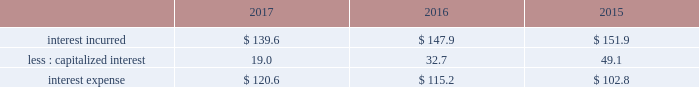Gain on previously held equity interest on 30 december 2014 , we acquired our partner 2019s equity ownership interest in a liquefied atmospheric industrial gases production joint venture in north america for $ 22.6 , which increased our ownership from 50% ( 50 % ) to 100% ( 100 % ) .
The transaction was accounted for as a business combination , and subsequent to the acquisition , the results were consolidated within our industrial gases 2013 americas segment .
We recorded a gain of $ 17.9 ( $ 11.2 after-tax , or $ .05 per share ) as a result of revaluing our previously held equity interest to fair value as of the acquisition date .
Refer to note 6 , business combination , to the consolidated financial statements for additional details .
Other income ( expense ) , net items recorded to other income ( expense ) , net arise from transactions and events not directly related to our principal income earning activities .
The detail of other income ( expense ) , net is presented in note 23 , supplemental information , to the consolidated financial statements .
2017 vs .
2016 other income ( expense ) , net of $ 121.0 increased $ 71.6 , primarily due to income from transition services agreements with versum and evonik , income from the sale of assets and investments , including a gain of $ 12.2 ( $ 7.6 after-tax , or $ .03 per share ) resulting from the sale of a parcel of land , and a favorable foreign exchange impact .
2016 vs .
2015 other income ( expense ) , net of $ 49.4 increased $ 3.9 , primarily due to lower foreign exchange losses , favorable contract settlements , and receipt of a government subsidy .
Fiscal year 2015 included a gain of $ 33.6 ( $ 28.3 after tax , or $ .13 per share ) resulting from the sale of two parcels of land .
No other individual items were significant in comparison to fiscal year 2015 .
Interest expense .
2017 vs .
2016 interest incurred decreased $ 8.3 as the impact from a lower average debt balance of $ 26 was partially offset by the impact from a higher average interest rate on the debt portfolio of $ 19 .
The change in capitalized interest was driven by a decrease in the carrying value of projects under construction , primarily as a result of our decision to exit from the energy-from-waste business .
2016 vs .
2015 interest incurred decreased $ 4.0 .
The decrease primarily resulted from a stronger u.s .
Dollar on the translation of foreign currency interest of $ 6 , partially offset by a higher average debt balance of $ 2 .
The change in capitalized interest was driven by a decrease in the carrying value of projects under construction , primarily as a result of our exit from the energy-from-waste business .
Other non-operating income ( expense ) , net other non-operating income ( expense ) , net of $ 29.0 in fiscal year 2017 primarily resulted from interest income on cash and time deposits , which are comprised primarily of proceeds from the sale of pmd .
Interest income was included in "other income ( expense ) , net" in 2016 and 2015 .
Interest income in previous periods was not material .
Loss on extinguishment of debt on 30 september 2016 , in anticipation of the spin-off of emd , versum issued $ 425.0 of notes to air products , who then exchanged these notes with certain financial institutions for $ 418.3 of air products 2019 outstanding commercial paper .
This noncash exchange , which was excluded from the consolidated statements of cash flows , resulted in a loss of $ 6.9 ( $ 4.3 after-tax , or $ .02 per share ) .
In september 2015 , we made a payment of $ 146.6 to redeem 3000000 unidades de fomento ( 201cuf 201d ) series e 6.30% ( 6.30 % ) bonds due 22 january 2030 that had a carrying value of $ 130.0 and resulted in a net loss of $ 16.6 ( $ 14.2 after-tax , or $ .07 per share ) . .
What is the decrease observed in the capitalized interest during 2015 and 2016? 
Rationale: it is the percentual variation observed during these years , which is calculated by subtracting the initial value ( 2015 ) of the final one ( 2016 ) then dividing by the initial and turned into a percentage .
Computations: ((32.7 - 49.1) / 49.1)
Answer: -0.33401. 